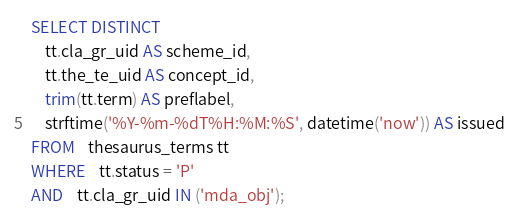Convert code to text. <code><loc_0><loc_0><loc_500><loc_500><_SQL_>SELECT DISTINCT
	tt.cla_gr_uid AS scheme_id,
	tt.the_te_uid AS concept_id,	
	trim(tt.term) AS preflabel,
	strftime('%Y-%m-%dT%H:%M:%S', datetime('now')) AS issued
FROM 	thesaurus_terms tt
WHERE 	tt.status = 'P' 
AND	tt.cla_gr_uid IN ('mda_obj');
</code> 